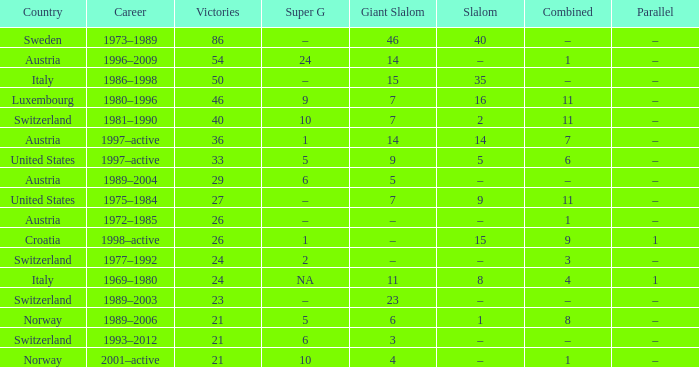What occupation has a super g of 5, and a combined of 6? 1997–active. 